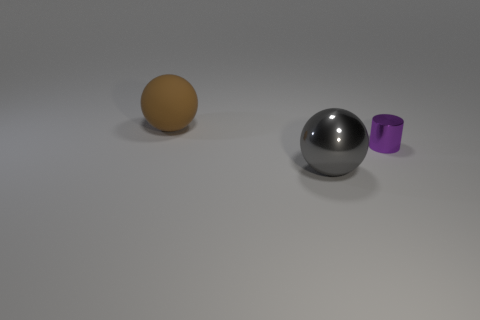What shape is the large gray thing?
Provide a short and direct response. Sphere. How many objects are large rubber balls or large spheres behind the small purple object?
Offer a very short reply. 1. There is a thing that is left of the tiny purple metallic object and behind the gray metal object; what is its color?
Your answer should be compact. Brown. There is a big object that is behind the purple thing; what is it made of?
Offer a terse response. Rubber. What is the size of the purple cylinder?
Ensure brevity in your answer.  Small. How many brown objects are either big matte objects or big metal balls?
Your answer should be very brief. 1. What size is the ball behind the big object that is in front of the large brown rubber ball?
Give a very brief answer. Large. There is a large metallic ball; is its color the same as the sphere behind the shiny cylinder?
Provide a short and direct response. No. How many other objects are the same material as the tiny cylinder?
Offer a very short reply. 1. What is the shape of the large gray object that is the same material as the tiny purple thing?
Give a very brief answer. Sphere. 